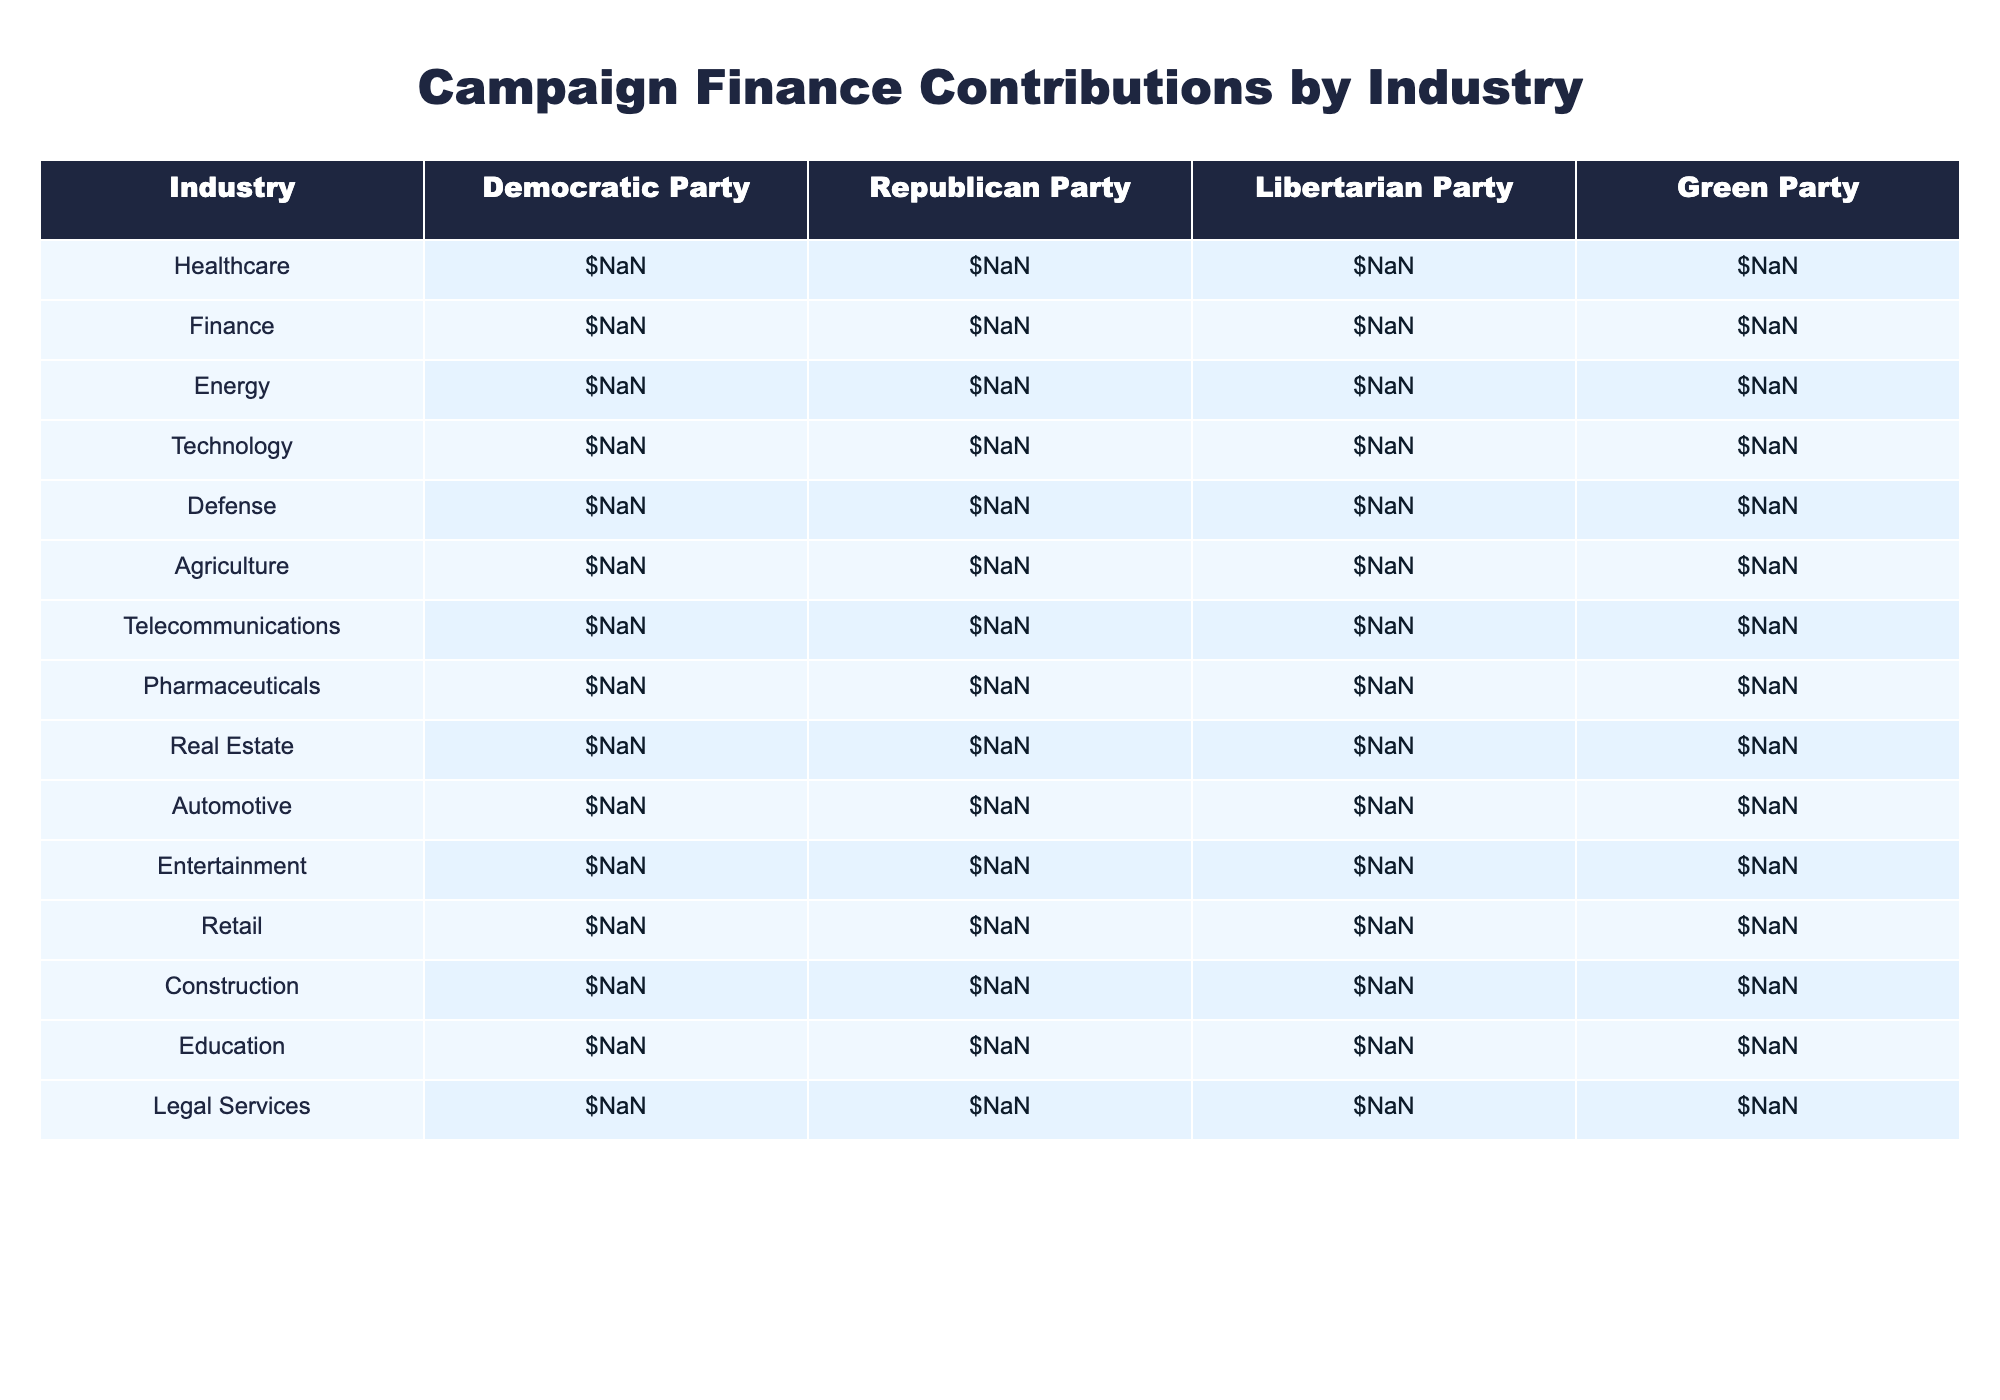What's the total contribution from the healthcare industry to all parties? To find the total contribution from the healthcare industry, I will sum the contributions from all parties: $45,200,000 (Democratic Party) + $38,700,000 (Republican Party) + $1,200,000 (Libertarian Party) + $850,000 (Green Party) = $86,950,000.
Answer: $86,950,000 Which party received the highest contribution from the finance industry? By looking at the finance row, the Republican Party received the highest contribution of $61,500,000.
Answer: Republican Party What is the difference in contributions to the technology industry between the Democratic Party and the Republican Party? The Democratic Party received $64,700,000, while the Republican Party received $39,800,000. The difference is $64,700,000 - $39,800,000 = $24,900,000.
Answer: $24,900,000 Which industry received the lowest total contributions across all parties? I will sum the contributions for each industry, and find that the defense industry received a total of $19,500,000 (Democratic Party) + $31,600,000 (Republican Party) + $580,000 (Libertarian Party) + $210,000 (Green Party) = $51,890,000, which is the lowest total contribution.
Answer: Defense Did any industry receive equal contributions from at least two parties? I will check the contributions for each industry and find that the telecommunications industry received $33,800,000 from the Democratic Party and $35,200,000 from the Republican Party, showing that no industry had equal contributions from two parties.
Answer: No What is the average contribution for the Republican Party across all industries? I will add the contributions for the Republican Party from each industry and divide by the number of industries: ($38,700,000 + $61,500,000 + $41,200,000 + $39,800,000 + $31,600,000 + $29,400,000 + $35,200,000 + $43,900,000 + $42,700,000 + $28,300,000 + $21,500,000 + $27,800,000) / 12 = $35,283,333.33.
Answer: $35,283,333.33 Which party had the highest contribution in the agriculture industry? In the agriculture row, the Republican Party received the highest contribution of $29,400,000.
Answer: Republican Party If we consider the top three industries for the Democratic Party, what is their total contribution? The top three industries for the Democratic Party based on the contributions are technology ($64,700,000), finance ($52,300,000), and healthcare ($45,200,000). Their total contribution is $64,700,000 + $52,300,000 + $45,200,000 = $162,200,000.
Answer: $162,200,000 Which party consistently receives the lowest contributions across multiple industries? I will review the table and find that the Green Party generally receives lower contributions across most industries compared to the other parties.
Answer: Green Party In which industry did the Libertarian Party receive more than $1 million in contributions? The only industry where the Libertarian Party received more than $1 million in contributions is pharmaceuticals, with $890,000, which is less than $1 million, therefore there are none.
Answer: None 